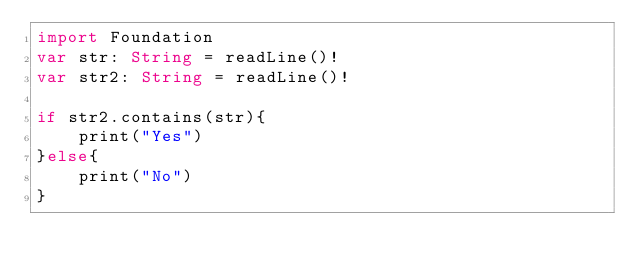Convert code to text. <code><loc_0><loc_0><loc_500><loc_500><_Swift_>import Foundation
var str: String = readLine()!
var str2: String = readLine()!

if str2.contains(str){
    print("Yes")
}else{
    print("No")
}</code> 